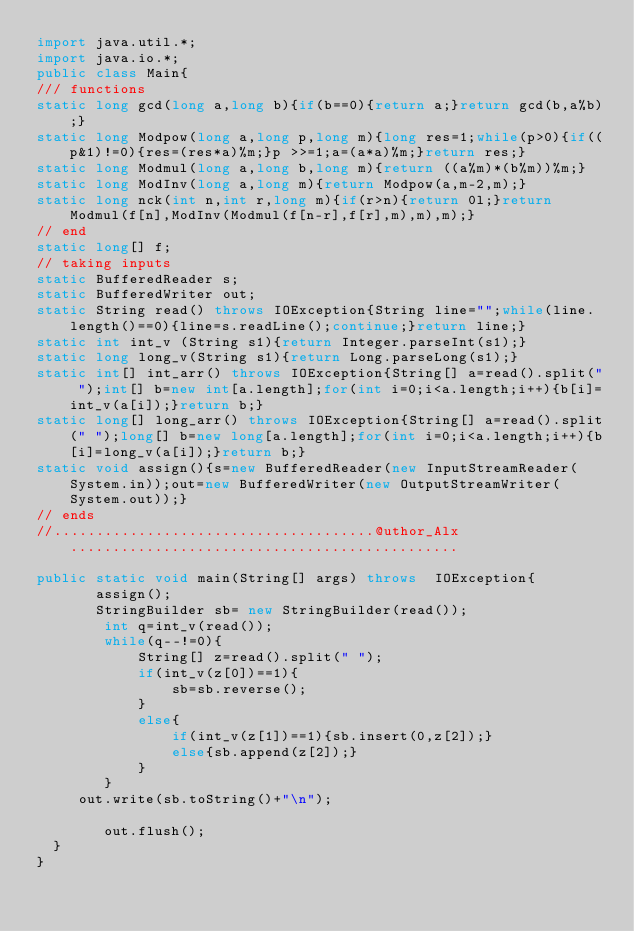Convert code to text. <code><loc_0><loc_0><loc_500><loc_500><_Java_>import java.util.*;
import java.io.*;
public class Main{
/// functions
static long gcd(long a,long b){if(b==0){return a;}return gcd(b,a%b);}
static long Modpow(long a,long p,long m){long res=1;while(p>0){if((p&1)!=0){res=(res*a)%m;}p >>=1;a=(a*a)%m;}return res;}
static long Modmul(long a,long b,long m){return ((a%m)*(b%m))%m;}
static long ModInv(long a,long m){return Modpow(a,m-2,m);}
static long nck(int n,int r,long m){if(r>n){return 0l;}return Modmul(f[n],ModInv(Modmul(f[n-r],f[r],m),m),m);}
// end
static long[] f;
// taking inputs
static BufferedReader s;
static BufferedWriter out;
static String read() throws IOException{String line="";while(line.length()==0){line=s.readLine();continue;}return line;}
static int int_v (String s1){return Integer.parseInt(s1);}
static long long_v(String s1){return Long.parseLong(s1);}
static int[] int_arr() throws IOException{String[] a=read().split(" ");int[] b=new int[a.length];for(int i=0;i<a.length;i++){b[i]=int_v(a[i]);}return b;}
static long[] long_arr() throws IOException{String[] a=read().split(" ");long[] b=new long[a.length];for(int i=0;i<a.length;i++){b[i]=long_v(a[i]);}return b;}
static void assign(){s=new BufferedReader(new InputStreamReader(System.in));out=new BufferedWriter(new OutputStreamWriter(System.out));}
// ends
//......................................@uthor_Alx..............................................

public static void main(String[] args) throws  IOException{
       assign();
       StringBuilder sb= new StringBuilder(read());
        int q=int_v(read());
        while(q--!=0){
        	String[] z=read().split(" ");
        	if(int_v(z[0])==1){
        		sb=sb.reverse();
        	}
        	else{
        		if(int_v(z[1])==1){sb.insert(0,z[2]);}
        		else{sb.append(z[2]);}
        	}
        }
     out.write(sb.toString()+"\n");
             
        out.flush();
  }
}
</code> 